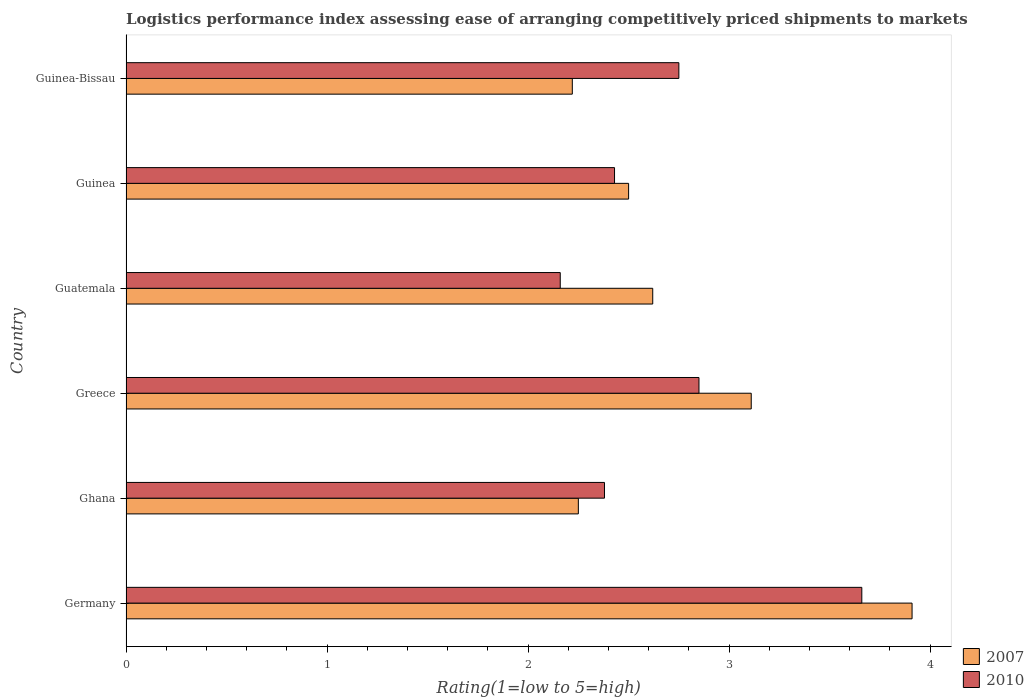How many different coloured bars are there?
Provide a short and direct response. 2. How many bars are there on the 2nd tick from the top?
Make the answer very short. 2. How many bars are there on the 5th tick from the bottom?
Give a very brief answer. 2. What is the label of the 5th group of bars from the top?
Your answer should be compact. Ghana. What is the Logistic performance index in 2007 in Greece?
Ensure brevity in your answer.  3.11. Across all countries, what is the maximum Logistic performance index in 2010?
Your answer should be very brief. 3.66. Across all countries, what is the minimum Logistic performance index in 2010?
Your answer should be very brief. 2.16. In which country was the Logistic performance index in 2010 maximum?
Provide a short and direct response. Germany. In which country was the Logistic performance index in 2007 minimum?
Make the answer very short. Guinea-Bissau. What is the total Logistic performance index in 2010 in the graph?
Make the answer very short. 16.23. What is the difference between the Logistic performance index in 2007 in Guinea and that in Guinea-Bissau?
Offer a very short reply. 0.28. What is the difference between the Logistic performance index in 2010 in Guatemala and the Logistic performance index in 2007 in Ghana?
Offer a terse response. -0.09. What is the average Logistic performance index in 2007 per country?
Offer a very short reply. 2.77. What is the difference between the Logistic performance index in 2010 and Logistic performance index in 2007 in Guinea?
Provide a short and direct response. -0.07. In how many countries, is the Logistic performance index in 2010 greater than 0.2 ?
Your answer should be very brief. 6. What is the ratio of the Logistic performance index in 2007 in Ghana to that in Greece?
Offer a terse response. 0.72. What is the difference between the highest and the second highest Logistic performance index in 2007?
Ensure brevity in your answer.  0.8. What is the difference between the highest and the lowest Logistic performance index in 2010?
Make the answer very short. 1.5. Is the sum of the Logistic performance index in 2007 in Germany and Guinea-Bissau greater than the maximum Logistic performance index in 2010 across all countries?
Provide a short and direct response. Yes. What does the 1st bar from the top in Guatemala represents?
Your answer should be compact. 2010. How many countries are there in the graph?
Give a very brief answer. 6. What is the difference between two consecutive major ticks on the X-axis?
Your response must be concise. 1. Does the graph contain grids?
Provide a short and direct response. No. Where does the legend appear in the graph?
Keep it short and to the point. Bottom right. How are the legend labels stacked?
Provide a succinct answer. Vertical. What is the title of the graph?
Offer a very short reply. Logistics performance index assessing ease of arranging competitively priced shipments to markets. Does "1970" appear as one of the legend labels in the graph?
Offer a terse response. No. What is the label or title of the X-axis?
Ensure brevity in your answer.  Rating(1=low to 5=high). What is the label or title of the Y-axis?
Your response must be concise. Country. What is the Rating(1=low to 5=high) of 2007 in Germany?
Your answer should be very brief. 3.91. What is the Rating(1=low to 5=high) in 2010 in Germany?
Offer a terse response. 3.66. What is the Rating(1=low to 5=high) of 2007 in Ghana?
Ensure brevity in your answer.  2.25. What is the Rating(1=low to 5=high) in 2010 in Ghana?
Offer a terse response. 2.38. What is the Rating(1=low to 5=high) of 2007 in Greece?
Provide a short and direct response. 3.11. What is the Rating(1=low to 5=high) of 2010 in Greece?
Offer a terse response. 2.85. What is the Rating(1=low to 5=high) in 2007 in Guatemala?
Your answer should be compact. 2.62. What is the Rating(1=low to 5=high) in 2010 in Guatemala?
Your answer should be compact. 2.16. What is the Rating(1=low to 5=high) of 2007 in Guinea?
Provide a short and direct response. 2.5. What is the Rating(1=low to 5=high) in 2010 in Guinea?
Keep it short and to the point. 2.43. What is the Rating(1=low to 5=high) of 2007 in Guinea-Bissau?
Your answer should be very brief. 2.22. What is the Rating(1=low to 5=high) in 2010 in Guinea-Bissau?
Provide a short and direct response. 2.75. Across all countries, what is the maximum Rating(1=low to 5=high) in 2007?
Ensure brevity in your answer.  3.91. Across all countries, what is the maximum Rating(1=low to 5=high) in 2010?
Ensure brevity in your answer.  3.66. Across all countries, what is the minimum Rating(1=low to 5=high) of 2007?
Your response must be concise. 2.22. Across all countries, what is the minimum Rating(1=low to 5=high) of 2010?
Provide a succinct answer. 2.16. What is the total Rating(1=low to 5=high) in 2007 in the graph?
Offer a very short reply. 16.61. What is the total Rating(1=low to 5=high) of 2010 in the graph?
Make the answer very short. 16.23. What is the difference between the Rating(1=low to 5=high) in 2007 in Germany and that in Ghana?
Your answer should be compact. 1.66. What is the difference between the Rating(1=low to 5=high) of 2010 in Germany and that in Ghana?
Provide a short and direct response. 1.28. What is the difference between the Rating(1=low to 5=high) of 2007 in Germany and that in Greece?
Provide a succinct answer. 0.8. What is the difference between the Rating(1=low to 5=high) in 2010 in Germany and that in Greece?
Provide a succinct answer. 0.81. What is the difference between the Rating(1=low to 5=high) in 2007 in Germany and that in Guatemala?
Your answer should be very brief. 1.29. What is the difference between the Rating(1=low to 5=high) in 2010 in Germany and that in Guatemala?
Keep it short and to the point. 1.5. What is the difference between the Rating(1=low to 5=high) of 2007 in Germany and that in Guinea?
Your answer should be compact. 1.41. What is the difference between the Rating(1=low to 5=high) in 2010 in Germany and that in Guinea?
Your answer should be compact. 1.23. What is the difference between the Rating(1=low to 5=high) of 2007 in Germany and that in Guinea-Bissau?
Your answer should be compact. 1.69. What is the difference between the Rating(1=low to 5=high) of 2010 in Germany and that in Guinea-Bissau?
Provide a short and direct response. 0.91. What is the difference between the Rating(1=low to 5=high) of 2007 in Ghana and that in Greece?
Your answer should be compact. -0.86. What is the difference between the Rating(1=low to 5=high) in 2010 in Ghana and that in Greece?
Provide a short and direct response. -0.47. What is the difference between the Rating(1=low to 5=high) in 2007 in Ghana and that in Guatemala?
Your answer should be compact. -0.37. What is the difference between the Rating(1=low to 5=high) in 2010 in Ghana and that in Guatemala?
Keep it short and to the point. 0.22. What is the difference between the Rating(1=low to 5=high) in 2007 in Ghana and that in Guinea?
Your answer should be compact. -0.25. What is the difference between the Rating(1=low to 5=high) in 2010 in Ghana and that in Guinea?
Provide a succinct answer. -0.05. What is the difference between the Rating(1=low to 5=high) in 2007 in Ghana and that in Guinea-Bissau?
Give a very brief answer. 0.03. What is the difference between the Rating(1=low to 5=high) of 2010 in Ghana and that in Guinea-Bissau?
Keep it short and to the point. -0.37. What is the difference between the Rating(1=low to 5=high) in 2007 in Greece and that in Guatemala?
Offer a terse response. 0.49. What is the difference between the Rating(1=low to 5=high) in 2010 in Greece and that in Guatemala?
Offer a very short reply. 0.69. What is the difference between the Rating(1=low to 5=high) of 2007 in Greece and that in Guinea?
Your response must be concise. 0.61. What is the difference between the Rating(1=low to 5=high) of 2010 in Greece and that in Guinea?
Offer a very short reply. 0.42. What is the difference between the Rating(1=low to 5=high) in 2007 in Greece and that in Guinea-Bissau?
Your response must be concise. 0.89. What is the difference between the Rating(1=low to 5=high) in 2010 in Greece and that in Guinea-Bissau?
Your response must be concise. 0.1. What is the difference between the Rating(1=low to 5=high) of 2007 in Guatemala and that in Guinea?
Your answer should be compact. 0.12. What is the difference between the Rating(1=low to 5=high) in 2010 in Guatemala and that in Guinea?
Keep it short and to the point. -0.27. What is the difference between the Rating(1=low to 5=high) in 2007 in Guatemala and that in Guinea-Bissau?
Your answer should be very brief. 0.4. What is the difference between the Rating(1=low to 5=high) in 2010 in Guatemala and that in Guinea-Bissau?
Your response must be concise. -0.59. What is the difference between the Rating(1=low to 5=high) in 2007 in Guinea and that in Guinea-Bissau?
Your answer should be very brief. 0.28. What is the difference between the Rating(1=low to 5=high) in 2010 in Guinea and that in Guinea-Bissau?
Keep it short and to the point. -0.32. What is the difference between the Rating(1=low to 5=high) in 2007 in Germany and the Rating(1=low to 5=high) in 2010 in Ghana?
Your answer should be very brief. 1.53. What is the difference between the Rating(1=low to 5=high) of 2007 in Germany and the Rating(1=low to 5=high) of 2010 in Greece?
Offer a terse response. 1.06. What is the difference between the Rating(1=low to 5=high) in 2007 in Germany and the Rating(1=low to 5=high) in 2010 in Guatemala?
Your answer should be compact. 1.75. What is the difference between the Rating(1=low to 5=high) in 2007 in Germany and the Rating(1=low to 5=high) in 2010 in Guinea?
Keep it short and to the point. 1.48. What is the difference between the Rating(1=low to 5=high) of 2007 in Germany and the Rating(1=low to 5=high) of 2010 in Guinea-Bissau?
Offer a very short reply. 1.16. What is the difference between the Rating(1=low to 5=high) in 2007 in Ghana and the Rating(1=low to 5=high) in 2010 in Greece?
Ensure brevity in your answer.  -0.6. What is the difference between the Rating(1=low to 5=high) of 2007 in Ghana and the Rating(1=low to 5=high) of 2010 in Guatemala?
Provide a succinct answer. 0.09. What is the difference between the Rating(1=low to 5=high) of 2007 in Ghana and the Rating(1=low to 5=high) of 2010 in Guinea?
Your response must be concise. -0.18. What is the difference between the Rating(1=low to 5=high) in 2007 in Ghana and the Rating(1=low to 5=high) in 2010 in Guinea-Bissau?
Your response must be concise. -0.5. What is the difference between the Rating(1=low to 5=high) of 2007 in Greece and the Rating(1=low to 5=high) of 2010 in Guinea?
Offer a very short reply. 0.68. What is the difference between the Rating(1=low to 5=high) of 2007 in Greece and the Rating(1=low to 5=high) of 2010 in Guinea-Bissau?
Offer a terse response. 0.36. What is the difference between the Rating(1=low to 5=high) of 2007 in Guatemala and the Rating(1=low to 5=high) of 2010 in Guinea?
Provide a short and direct response. 0.19. What is the difference between the Rating(1=low to 5=high) in 2007 in Guatemala and the Rating(1=low to 5=high) in 2010 in Guinea-Bissau?
Ensure brevity in your answer.  -0.13. What is the difference between the Rating(1=low to 5=high) of 2007 in Guinea and the Rating(1=low to 5=high) of 2010 in Guinea-Bissau?
Provide a succinct answer. -0.25. What is the average Rating(1=low to 5=high) of 2007 per country?
Make the answer very short. 2.77. What is the average Rating(1=low to 5=high) in 2010 per country?
Provide a succinct answer. 2.71. What is the difference between the Rating(1=low to 5=high) in 2007 and Rating(1=low to 5=high) in 2010 in Germany?
Offer a very short reply. 0.25. What is the difference between the Rating(1=low to 5=high) of 2007 and Rating(1=low to 5=high) of 2010 in Ghana?
Offer a very short reply. -0.13. What is the difference between the Rating(1=low to 5=high) of 2007 and Rating(1=low to 5=high) of 2010 in Greece?
Your answer should be compact. 0.26. What is the difference between the Rating(1=low to 5=high) of 2007 and Rating(1=low to 5=high) of 2010 in Guatemala?
Your answer should be compact. 0.46. What is the difference between the Rating(1=low to 5=high) in 2007 and Rating(1=low to 5=high) in 2010 in Guinea?
Ensure brevity in your answer.  0.07. What is the difference between the Rating(1=low to 5=high) of 2007 and Rating(1=low to 5=high) of 2010 in Guinea-Bissau?
Offer a terse response. -0.53. What is the ratio of the Rating(1=low to 5=high) in 2007 in Germany to that in Ghana?
Give a very brief answer. 1.74. What is the ratio of the Rating(1=low to 5=high) in 2010 in Germany to that in Ghana?
Your answer should be very brief. 1.54. What is the ratio of the Rating(1=low to 5=high) in 2007 in Germany to that in Greece?
Offer a very short reply. 1.26. What is the ratio of the Rating(1=low to 5=high) of 2010 in Germany to that in Greece?
Your answer should be compact. 1.28. What is the ratio of the Rating(1=low to 5=high) of 2007 in Germany to that in Guatemala?
Give a very brief answer. 1.49. What is the ratio of the Rating(1=low to 5=high) in 2010 in Germany to that in Guatemala?
Make the answer very short. 1.69. What is the ratio of the Rating(1=low to 5=high) in 2007 in Germany to that in Guinea?
Make the answer very short. 1.56. What is the ratio of the Rating(1=low to 5=high) of 2010 in Germany to that in Guinea?
Give a very brief answer. 1.51. What is the ratio of the Rating(1=low to 5=high) in 2007 in Germany to that in Guinea-Bissau?
Your response must be concise. 1.76. What is the ratio of the Rating(1=low to 5=high) of 2010 in Germany to that in Guinea-Bissau?
Your response must be concise. 1.33. What is the ratio of the Rating(1=low to 5=high) in 2007 in Ghana to that in Greece?
Offer a terse response. 0.72. What is the ratio of the Rating(1=low to 5=high) in 2010 in Ghana to that in Greece?
Provide a short and direct response. 0.84. What is the ratio of the Rating(1=low to 5=high) in 2007 in Ghana to that in Guatemala?
Offer a terse response. 0.86. What is the ratio of the Rating(1=low to 5=high) of 2010 in Ghana to that in Guatemala?
Your answer should be compact. 1.1. What is the ratio of the Rating(1=low to 5=high) of 2007 in Ghana to that in Guinea?
Make the answer very short. 0.9. What is the ratio of the Rating(1=low to 5=high) in 2010 in Ghana to that in Guinea?
Your response must be concise. 0.98. What is the ratio of the Rating(1=low to 5=high) of 2007 in Ghana to that in Guinea-Bissau?
Your response must be concise. 1.01. What is the ratio of the Rating(1=low to 5=high) in 2010 in Ghana to that in Guinea-Bissau?
Offer a terse response. 0.87. What is the ratio of the Rating(1=low to 5=high) of 2007 in Greece to that in Guatemala?
Give a very brief answer. 1.19. What is the ratio of the Rating(1=low to 5=high) of 2010 in Greece to that in Guatemala?
Provide a short and direct response. 1.32. What is the ratio of the Rating(1=low to 5=high) in 2007 in Greece to that in Guinea?
Make the answer very short. 1.24. What is the ratio of the Rating(1=low to 5=high) in 2010 in Greece to that in Guinea?
Make the answer very short. 1.17. What is the ratio of the Rating(1=low to 5=high) of 2007 in Greece to that in Guinea-Bissau?
Offer a terse response. 1.4. What is the ratio of the Rating(1=low to 5=high) in 2010 in Greece to that in Guinea-Bissau?
Give a very brief answer. 1.04. What is the ratio of the Rating(1=low to 5=high) of 2007 in Guatemala to that in Guinea?
Make the answer very short. 1.05. What is the ratio of the Rating(1=low to 5=high) in 2010 in Guatemala to that in Guinea?
Keep it short and to the point. 0.89. What is the ratio of the Rating(1=low to 5=high) in 2007 in Guatemala to that in Guinea-Bissau?
Keep it short and to the point. 1.18. What is the ratio of the Rating(1=low to 5=high) in 2010 in Guatemala to that in Guinea-Bissau?
Your answer should be compact. 0.79. What is the ratio of the Rating(1=low to 5=high) of 2007 in Guinea to that in Guinea-Bissau?
Ensure brevity in your answer.  1.13. What is the ratio of the Rating(1=low to 5=high) of 2010 in Guinea to that in Guinea-Bissau?
Ensure brevity in your answer.  0.88. What is the difference between the highest and the second highest Rating(1=low to 5=high) of 2010?
Provide a short and direct response. 0.81. What is the difference between the highest and the lowest Rating(1=low to 5=high) in 2007?
Offer a terse response. 1.69. 